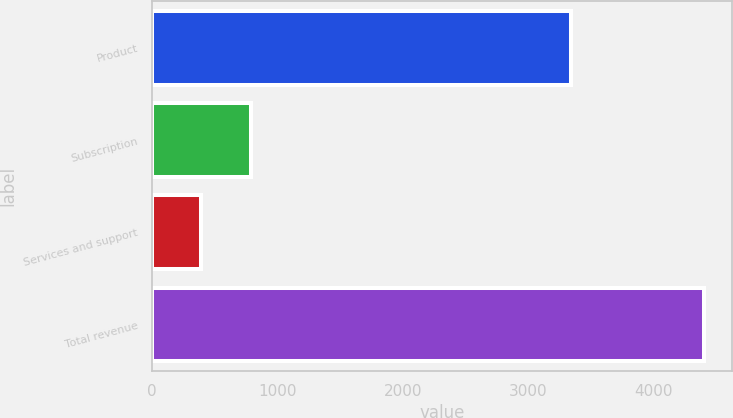<chart> <loc_0><loc_0><loc_500><loc_500><bar_chart><fcel>Product<fcel>Subscription<fcel>Services and support<fcel>Total revenue<nl><fcel>3342.8<fcel>789.3<fcel>387.7<fcel>4403.7<nl></chart> 